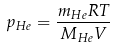Convert formula to latex. <formula><loc_0><loc_0><loc_500><loc_500>p _ { H e } = \frac { m _ { H e } R T } { M _ { H e } V }</formula> 